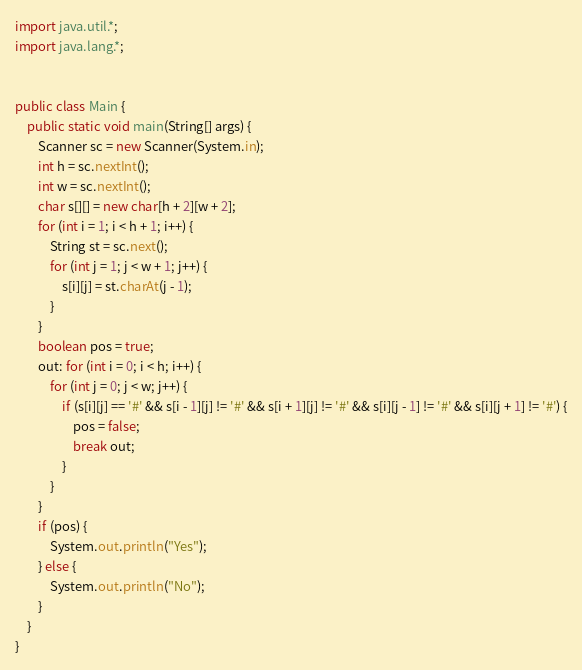<code> <loc_0><loc_0><loc_500><loc_500><_Java_>import java.util.*;
import java.lang.*;


public class Main {
    public static void main(String[] args) {
        Scanner sc = new Scanner(System.in);
        int h = sc.nextInt();
        int w = sc.nextInt();
        char s[][] = new char[h + 2][w + 2];
        for (int i = 1; i < h + 1; i++) {
            String st = sc.next();
            for (int j = 1; j < w + 1; j++) {
                s[i][j] = st.charAt(j - 1);
            }
        }
        boolean pos = true;
        out: for (int i = 0; i < h; i++) {
            for (int j = 0; j < w; j++) {
                if (s[i][j] == '#' && s[i - 1][j] != '#' && s[i + 1][j] != '#' && s[i][j - 1] != '#' && s[i][j + 1] != '#') {
                    pos = false;
                    break out;
                }
            }
        }
        if (pos) {
            System.out.println("Yes");
        } else {
            System.out.println("No");
        }
    }
}</code> 